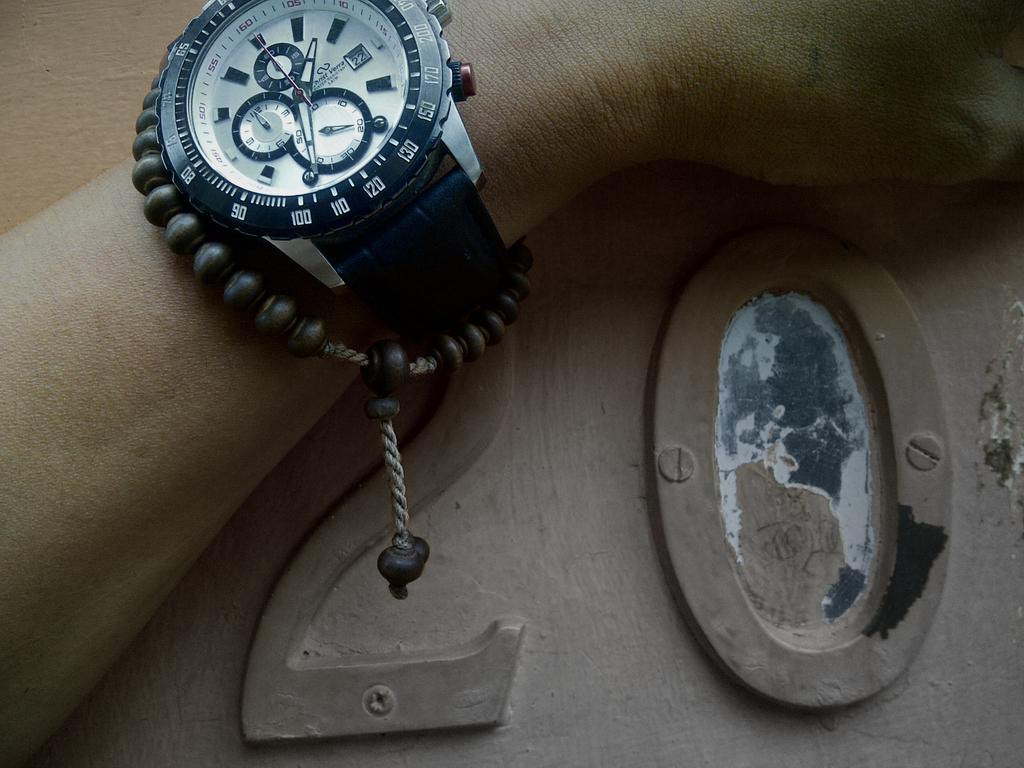<image>
Offer a succinct explanation of the picture presented. An analog wrist watch showing a little passed 1:30. 